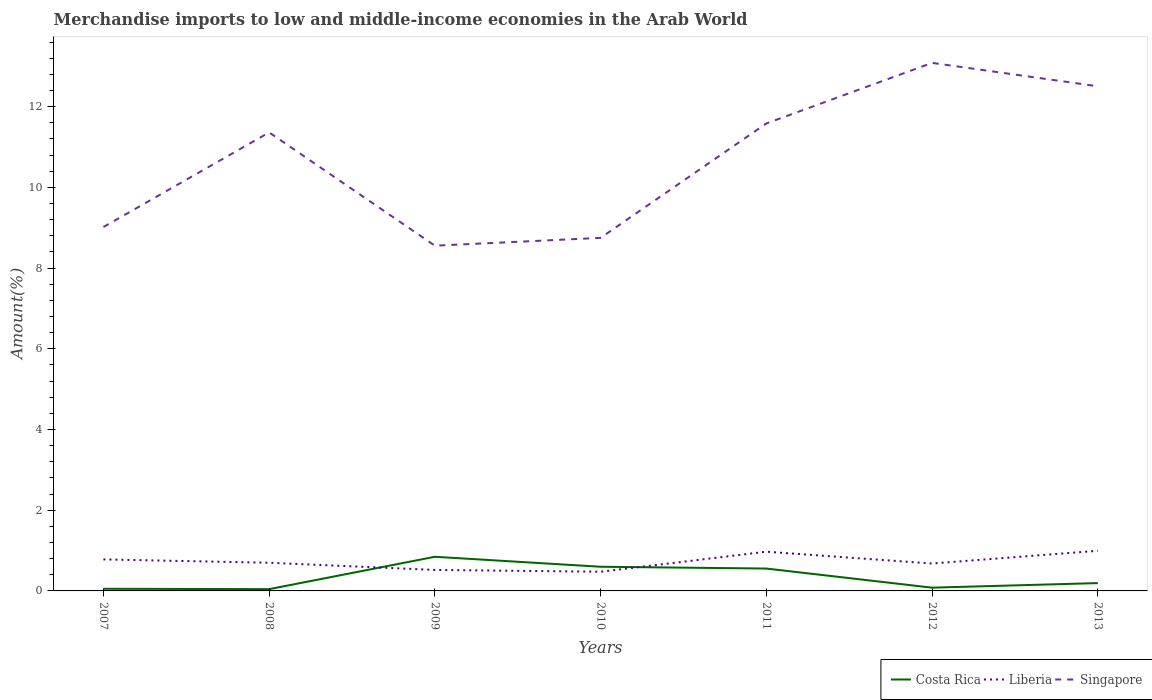Across all years, what is the maximum percentage of amount earned from merchandise imports in Costa Rica?
Offer a terse response. 0.04. In which year was the percentage of amount earned from merchandise imports in Singapore maximum?
Make the answer very short. 2009. What is the total percentage of amount earned from merchandise imports in Costa Rica in the graph?
Offer a very short reply. -0.51. What is the difference between the highest and the second highest percentage of amount earned from merchandise imports in Liberia?
Your response must be concise. 0.52. What is the difference between the highest and the lowest percentage of amount earned from merchandise imports in Singapore?
Provide a short and direct response. 4. How many lines are there?
Your response must be concise. 3. What is the difference between two consecutive major ticks on the Y-axis?
Keep it short and to the point. 2. Are the values on the major ticks of Y-axis written in scientific E-notation?
Provide a short and direct response. No. Does the graph contain any zero values?
Provide a succinct answer. No. Where does the legend appear in the graph?
Give a very brief answer. Bottom right. How many legend labels are there?
Your answer should be compact. 3. What is the title of the graph?
Give a very brief answer. Merchandise imports to low and middle-income economies in the Arab World. Does "Eritrea" appear as one of the legend labels in the graph?
Your response must be concise. No. What is the label or title of the Y-axis?
Your answer should be compact. Amount(%). What is the Amount(%) of Costa Rica in 2007?
Keep it short and to the point. 0.05. What is the Amount(%) of Liberia in 2007?
Provide a short and direct response. 0.78. What is the Amount(%) in Singapore in 2007?
Offer a very short reply. 9.02. What is the Amount(%) in Costa Rica in 2008?
Keep it short and to the point. 0.04. What is the Amount(%) of Liberia in 2008?
Give a very brief answer. 0.7. What is the Amount(%) in Singapore in 2008?
Make the answer very short. 11.36. What is the Amount(%) in Costa Rica in 2009?
Keep it short and to the point. 0.85. What is the Amount(%) in Liberia in 2009?
Offer a terse response. 0.52. What is the Amount(%) in Singapore in 2009?
Provide a short and direct response. 8.56. What is the Amount(%) of Costa Rica in 2010?
Give a very brief answer. 0.6. What is the Amount(%) in Liberia in 2010?
Give a very brief answer. 0.48. What is the Amount(%) of Singapore in 2010?
Ensure brevity in your answer.  8.75. What is the Amount(%) in Costa Rica in 2011?
Ensure brevity in your answer.  0.55. What is the Amount(%) of Liberia in 2011?
Make the answer very short. 0.97. What is the Amount(%) of Singapore in 2011?
Your answer should be compact. 11.58. What is the Amount(%) in Costa Rica in 2012?
Offer a very short reply. 0.08. What is the Amount(%) of Liberia in 2012?
Offer a very short reply. 0.68. What is the Amount(%) in Singapore in 2012?
Your response must be concise. 13.09. What is the Amount(%) of Costa Rica in 2013?
Offer a very short reply. 0.19. What is the Amount(%) of Liberia in 2013?
Provide a short and direct response. 0.99. What is the Amount(%) of Singapore in 2013?
Offer a terse response. 12.51. Across all years, what is the maximum Amount(%) in Costa Rica?
Your response must be concise. 0.85. Across all years, what is the maximum Amount(%) of Liberia?
Give a very brief answer. 0.99. Across all years, what is the maximum Amount(%) in Singapore?
Make the answer very short. 13.09. Across all years, what is the minimum Amount(%) in Costa Rica?
Ensure brevity in your answer.  0.04. Across all years, what is the minimum Amount(%) of Liberia?
Your answer should be very brief. 0.48. Across all years, what is the minimum Amount(%) in Singapore?
Offer a terse response. 8.56. What is the total Amount(%) of Costa Rica in the graph?
Your response must be concise. 2.37. What is the total Amount(%) in Liberia in the graph?
Provide a succinct answer. 5.12. What is the total Amount(%) of Singapore in the graph?
Offer a very short reply. 74.86. What is the difference between the Amount(%) of Costa Rica in 2007 and that in 2008?
Provide a short and direct response. 0.01. What is the difference between the Amount(%) of Liberia in 2007 and that in 2008?
Make the answer very short. 0.08. What is the difference between the Amount(%) of Singapore in 2007 and that in 2008?
Offer a very short reply. -2.34. What is the difference between the Amount(%) in Costa Rica in 2007 and that in 2009?
Offer a very short reply. -0.79. What is the difference between the Amount(%) of Liberia in 2007 and that in 2009?
Ensure brevity in your answer.  0.26. What is the difference between the Amount(%) of Singapore in 2007 and that in 2009?
Give a very brief answer. 0.46. What is the difference between the Amount(%) of Costa Rica in 2007 and that in 2010?
Keep it short and to the point. -0.55. What is the difference between the Amount(%) in Liberia in 2007 and that in 2010?
Make the answer very short. 0.31. What is the difference between the Amount(%) of Singapore in 2007 and that in 2010?
Offer a terse response. 0.27. What is the difference between the Amount(%) in Costa Rica in 2007 and that in 2011?
Your answer should be compact. -0.5. What is the difference between the Amount(%) in Liberia in 2007 and that in 2011?
Your response must be concise. -0.19. What is the difference between the Amount(%) of Singapore in 2007 and that in 2011?
Your answer should be very brief. -2.57. What is the difference between the Amount(%) of Costa Rica in 2007 and that in 2012?
Your answer should be very brief. -0.03. What is the difference between the Amount(%) in Liberia in 2007 and that in 2012?
Your response must be concise. 0.1. What is the difference between the Amount(%) of Singapore in 2007 and that in 2012?
Your answer should be very brief. -4.07. What is the difference between the Amount(%) in Costa Rica in 2007 and that in 2013?
Offer a terse response. -0.14. What is the difference between the Amount(%) in Liberia in 2007 and that in 2013?
Your answer should be very brief. -0.21. What is the difference between the Amount(%) of Singapore in 2007 and that in 2013?
Offer a terse response. -3.49. What is the difference between the Amount(%) in Costa Rica in 2008 and that in 2009?
Your answer should be very brief. -0.8. What is the difference between the Amount(%) in Liberia in 2008 and that in 2009?
Your answer should be compact. 0.18. What is the difference between the Amount(%) of Singapore in 2008 and that in 2009?
Provide a short and direct response. 2.81. What is the difference between the Amount(%) in Costa Rica in 2008 and that in 2010?
Give a very brief answer. -0.56. What is the difference between the Amount(%) in Liberia in 2008 and that in 2010?
Provide a succinct answer. 0.22. What is the difference between the Amount(%) in Singapore in 2008 and that in 2010?
Keep it short and to the point. 2.61. What is the difference between the Amount(%) of Costa Rica in 2008 and that in 2011?
Keep it short and to the point. -0.51. What is the difference between the Amount(%) of Liberia in 2008 and that in 2011?
Ensure brevity in your answer.  -0.27. What is the difference between the Amount(%) of Singapore in 2008 and that in 2011?
Your answer should be compact. -0.22. What is the difference between the Amount(%) of Costa Rica in 2008 and that in 2012?
Your answer should be compact. -0.04. What is the difference between the Amount(%) of Liberia in 2008 and that in 2012?
Offer a very short reply. 0.02. What is the difference between the Amount(%) in Singapore in 2008 and that in 2012?
Offer a very short reply. -1.72. What is the difference between the Amount(%) in Costa Rica in 2008 and that in 2013?
Keep it short and to the point. -0.15. What is the difference between the Amount(%) of Liberia in 2008 and that in 2013?
Provide a succinct answer. -0.3. What is the difference between the Amount(%) of Singapore in 2008 and that in 2013?
Ensure brevity in your answer.  -1.14. What is the difference between the Amount(%) of Costa Rica in 2009 and that in 2010?
Your response must be concise. 0.25. What is the difference between the Amount(%) in Liberia in 2009 and that in 2010?
Keep it short and to the point. 0.04. What is the difference between the Amount(%) in Singapore in 2009 and that in 2010?
Ensure brevity in your answer.  -0.19. What is the difference between the Amount(%) in Costa Rica in 2009 and that in 2011?
Give a very brief answer. 0.29. What is the difference between the Amount(%) of Liberia in 2009 and that in 2011?
Offer a very short reply. -0.45. What is the difference between the Amount(%) in Singapore in 2009 and that in 2011?
Your response must be concise. -3.03. What is the difference between the Amount(%) in Costa Rica in 2009 and that in 2012?
Provide a short and direct response. 0.77. What is the difference between the Amount(%) of Liberia in 2009 and that in 2012?
Provide a short and direct response. -0.16. What is the difference between the Amount(%) of Singapore in 2009 and that in 2012?
Make the answer very short. -4.53. What is the difference between the Amount(%) of Costa Rica in 2009 and that in 2013?
Offer a very short reply. 0.65. What is the difference between the Amount(%) of Liberia in 2009 and that in 2013?
Offer a terse response. -0.47. What is the difference between the Amount(%) in Singapore in 2009 and that in 2013?
Give a very brief answer. -3.95. What is the difference between the Amount(%) in Costa Rica in 2010 and that in 2011?
Your answer should be very brief. 0.04. What is the difference between the Amount(%) in Liberia in 2010 and that in 2011?
Your response must be concise. -0.5. What is the difference between the Amount(%) of Singapore in 2010 and that in 2011?
Give a very brief answer. -2.83. What is the difference between the Amount(%) in Costa Rica in 2010 and that in 2012?
Ensure brevity in your answer.  0.52. What is the difference between the Amount(%) of Liberia in 2010 and that in 2012?
Keep it short and to the point. -0.2. What is the difference between the Amount(%) in Singapore in 2010 and that in 2012?
Your answer should be compact. -4.34. What is the difference between the Amount(%) of Costa Rica in 2010 and that in 2013?
Your answer should be compact. 0.41. What is the difference between the Amount(%) of Liberia in 2010 and that in 2013?
Offer a very short reply. -0.52. What is the difference between the Amount(%) in Singapore in 2010 and that in 2013?
Offer a very short reply. -3.76. What is the difference between the Amount(%) of Costa Rica in 2011 and that in 2012?
Provide a succinct answer. 0.47. What is the difference between the Amount(%) in Liberia in 2011 and that in 2012?
Ensure brevity in your answer.  0.29. What is the difference between the Amount(%) of Singapore in 2011 and that in 2012?
Your answer should be compact. -1.5. What is the difference between the Amount(%) in Costa Rica in 2011 and that in 2013?
Offer a very short reply. 0.36. What is the difference between the Amount(%) in Liberia in 2011 and that in 2013?
Make the answer very short. -0.02. What is the difference between the Amount(%) in Singapore in 2011 and that in 2013?
Give a very brief answer. -0.92. What is the difference between the Amount(%) of Costa Rica in 2012 and that in 2013?
Provide a succinct answer. -0.11. What is the difference between the Amount(%) in Liberia in 2012 and that in 2013?
Provide a succinct answer. -0.32. What is the difference between the Amount(%) of Singapore in 2012 and that in 2013?
Provide a short and direct response. 0.58. What is the difference between the Amount(%) of Costa Rica in 2007 and the Amount(%) of Liberia in 2008?
Offer a very short reply. -0.65. What is the difference between the Amount(%) of Costa Rica in 2007 and the Amount(%) of Singapore in 2008?
Give a very brief answer. -11.31. What is the difference between the Amount(%) in Liberia in 2007 and the Amount(%) in Singapore in 2008?
Provide a short and direct response. -10.58. What is the difference between the Amount(%) of Costa Rica in 2007 and the Amount(%) of Liberia in 2009?
Offer a terse response. -0.47. What is the difference between the Amount(%) in Costa Rica in 2007 and the Amount(%) in Singapore in 2009?
Provide a short and direct response. -8.5. What is the difference between the Amount(%) in Liberia in 2007 and the Amount(%) in Singapore in 2009?
Give a very brief answer. -7.77. What is the difference between the Amount(%) of Costa Rica in 2007 and the Amount(%) of Liberia in 2010?
Your answer should be compact. -0.42. What is the difference between the Amount(%) of Costa Rica in 2007 and the Amount(%) of Singapore in 2010?
Give a very brief answer. -8.7. What is the difference between the Amount(%) of Liberia in 2007 and the Amount(%) of Singapore in 2010?
Offer a very short reply. -7.97. What is the difference between the Amount(%) of Costa Rica in 2007 and the Amount(%) of Liberia in 2011?
Give a very brief answer. -0.92. What is the difference between the Amount(%) in Costa Rica in 2007 and the Amount(%) in Singapore in 2011?
Your answer should be compact. -11.53. What is the difference between the Amount(%) of Liberia in 2007 and the Amount(%) of Singapore in 2011?
Offer a very short reply. -10.8. What is the difference between the Amount(%) in Costa Rica in 2007 and the Amount(%) in Liberia in 2012?
Provide a succinct answer. -0.63. What is the difference between the Amount(%) of Costa Rica in 2007 and the Amount(%) of Singapore in 2012?
Provide a succinct answer. -13.03. What is the difference between the Amount(%) of Liberia in 2007 and the Amount(%) of Singapore in 2012?
Give a very brief answer. -12.3. What is the difference between the Amount(%) of Costa Rica in 2007 and the Amount(%) of Liberia in 2013?
Offer a terse response. -0.94. What is the difference between the Amount(%) in Costa Rica in 2007 and the Amount(%) in Singapore in 2013?
Your answer should be very brief. -12.45. What is the difference between the Amount(%) in Liberia in 2007 and the Amount(%) in Singapore in 2013?
Provide a succinct answer. -11.72. What is the difference between the Amount(%) in Costa Rica in 2008 and the Amount(%) in Liberia in 2009?
Give a very brief answer. -0.48. What is the difference between the Amount(%) of Costa Rica in 2008 and the Amount(%) of Singapore in 2009?
Offer a terse response. -8.51. What is the difference between the Amount(%) of Liberia in 2008 and the Amount(%) of Singapore in 2009?
Provide a succinct answer. -7.86. What is the difference between the Amount(%) in Costa Rica in 2008 and the Amount(%) in Liberia in 2010?
Offer a very short reply. -0.43. What is the difference between the Amount(%) of Costa Rica in 2008 and the Amount(%) of Singapore in 2010?
Give a very brief answer. -8.71. What is the difference between the Amount(%) in Liberia in 2008 and the Amount(%) in Singapore in 2010?
Your answer should be compact. -8.05. What is the difference between the Amount(%) of Costa Rica in 2008 and the Amount(%) of Liberia in 2011?
Offer a terse response. -0.93. What is the difference between the Amount(%) of Costa Rica in 2008 and the Amount(%) of Singapore in 2011?
Make the answer very short. -11.54. What is the difference between the Amount(%) in Liberia in 2008 and the Amount(%) in Singapore in 2011?
Make the answer very short. -10.89. What is the difference between the Amount(%) of Costa Rica in 2008 and the Amount(%) of Liberia in 2012?
Offer a terse response. -0.64. What is the difference between the Amount(%) in Costa Rica in 2008 and the Amount(%) in Singapore in 2012?
Offer a terse response. -13.04. What is the difference between the Amount(%) in Liberia in 2008 and the Amount(%) in Singapore in 2012?
Offer a terse response. -12.39. What is the difference between the Amount(%) in Costa Rica in 2008 and the Amount(%) in Liberia in 2013?
Keep it short and to the point. -0.95. What is the difference between the Amount(%) of Costa Rica in 2008 and the Amount(%) of Singapore in 2013?
Offer a terse response. -12.46. What is the difference between the Amount(%) in Liberia in 2008 and the Amount(%) in Singapore in 2013?
Offer a terse response. -11.81. What is the difference between the Amount(%) in Costa Rica in 2009 and the Amount(%) in Liberia in 2010?
Your answer should be compact. 0.37. What is the difference between the Amount(%) of Costa Rica in 2009 and the Amount(%) of Singapore in 2010?
Your response must be concise. -7.9. What is the difference between the Amount(%) in Liberia in 2009 and the Amount(%) in Singapore in 2010?
Ensure brevity in your answer.  -8.23. What is the difference between the Amount(%) in Costa Rica in 2009 and the Amount(%) in Liberia in 2011?
Give a very brief answer. -0.13. What is the difference between the Amount(%) in Costa Rica in 2009 and the Amount(%) in Singapore in 2011?
Make the answer very short. -10.74. What is the difference between the Amount(%) of Liberia in 2009 and the Amount(%) of Singapore in 2011?
Make the answer very short. -11.06. What is the difference between the Amount(%) in Costa Rica in 2009 and the Amount(%) in Liberia in 2012?
Provide a short and direct response. 0.17. What is the difference between the Amount(%) of Costa Rica in 2009 and the Amount(%) of Singapore in 2012?
Keep it short and to the point. -12.24. What is the difference between the Amount(%) in Liberia in 2009 and the Amount(%) in Singapore in 2012?
Your answer should be very brief. -12.57. What is the difference between the Amount(%) of Costa Rica in 2009 and the Amount(%) of Liberia in 2013?
Your response must be concise. -0.15. What is the difference between the Amount(%) in Costa Rica in 2009 and the Amount(%) in Singapore in 2013?
Provide a short and direct response. -11.66. What is the difference between the Amount(%) in Liberia in 2009 and the Amount(%) in Singapore in 2013?
Your answer should be very brief. -11.99. What is the difference between the Amount(%) in Costa Rica in 2010 and the Amount(%) in Liberia in 2011?
Offer a terse response. -0.37. What is the difference between the Amount(%) in Costa Rica in 2010 and the Amount(%) in Singapore in 2011?
Your response must be concise. -10.99. What is the difference between the Amount(%) in Liberia in 2010 and the Amount(%) in Singapore in 2011?
Give a very brief answer. -11.11. What is the difference between the Amount(%) in Costa Rica in 2010 and the Amount(%) in Liberia in 2012?
Provide a succinct answer. -0.08. What is the difference between the Amount(%) of Costa Rica in 2010 and the Amount(%) of Singapore in 2012?
Ensure brevity in your answer.  -12.49. What is the difference between the Amount(%) of Liberia in 2010 and the Amount(%) of Singapore in 2012?
Provide a short and direct response. -12.61. What is the difference between the Amount(%) of Costa Rica in 2010 and the Amount(%) of Liberia in 2013?
Provide a short and direct response. -0.4. What is the difference between the Amount(%) of Costa Rica in 2010 and the Amount(%) of Singapore in 2013?
Provide a short and direct response. -11.91. What is the difference between the Amount(%) of Liberia in 2010 and the Amount(%) of Singapore in 2013?
Provide a succinct answer. -12.03. What is the difference between the Amount(%) of Costa Rica in 2011 and the Amount(%) of Liberia in 2012?
Make the answer very short. -0.12. What is the difference between the Amount(%) of Costa Rica in 2011 and the Amount(%) of Singapore in 2012?
Your response must be concise. -12.53. What is the difference between the Amount(%) of Liberia in 2011 and the Amount(%) of Singapore in 2012?
Offer a very short reply. -12.11. What is the difference between the Amount(%) of Costa Rica in 2011 and the Amount(%) of Liberia in 2013?
Ensure brevity in your answer.  -0.44. What is the difference between the Amount(%) in Costa Rica in 2011 and the Amount(%) in Singapore in 2013?
Ensure brevity in your answer.  -11.95. What is the difference between the Amount(%) of Liberia in 2011 and the Amount(%) of Singapore in 2013?
Provide a succinct answer. -11.53. What is the difference between the Amount(%) of Costa Rica in 2012 and the Amount(%) of Liberia in 2013?
Make the answer very short. -0.91. What is the difference between the Amount(%) of Costa Rica in 2012 and the Amount(%) of Singapore in 2013?
Provide a succinct answer. -12.43. What is the difference between the Amount(%) of Liberia in 2012 and the Amount(%) of Singapore in 2013?
Provide a succinct answer. -11.83. What is the average Amount(%) in Costa Rica per year?
Keep it short and to the point. 0.34. What is the average Amount(%) in Liberia per year?
Make the answer very short. 0.73. What is the average Amount(%) in Singapore per year?
Provide a succinct answer. 10.69. In the year 2007, what is the difference between the Amount(%) of Costa Rica and Amount(%) of Liberia?
Your answer should be compact. -0.73. In the year 2007, what is the difference between the Amount(%) of Costa Rica and Amount(%) of Singapore?
Provide a short and direct response. -8.97. In the year 2007, what is the difference between the Amount(%) in Liberia and Amount(%) in Singapore?
Your answer should be very brief. -8.24. In the year 2008, what is the difference between the Amount(%) of Costa Rica and Amount(%) of Liberia?
Your response must be concise. -0.65. In the year 2008, what is the difference between the Amount(%) in Costa Rica and Amount(%) in Singapore?
Make the answer very short. -11.32. In the year 2008, what is the difference between the Amount(%) of Liberia and Amount(%) of Singapore?
Ensure brevity in your answer.  -10.66. In the year 2009, what is the difference between the Amount(%) of Costa Rica and Amount(%) of Liberia?
Your response must be concise. 0.33. In the year 2009, what is the difference between the Amount(%) in Costa Rica and Amount(%) in Singapore?
Your response must be concise. -7.71. In the year 2009, what is the difference between the Amount(%) in Liberia and Amount(%) in Singapore?
Your answer should be compact. -8.03. In the year 2010, what is the difference between the Amount(%) of Costa Rica and Amount(%) of Liberia?
Your answer should be compact. 0.12. In the year 2010, what is the difference between the Amount(%) in Costa Rica and Amount(%) in Singapore?
Offer a terse response. -8.15. In the year 2010, what is the difference between the Amount(%) in Liberia and Amount(%) in Singapore?
Offer a terse response. -8.27. In the year 2011, what is the difference between the Amount(%) in Costa Rica and Amount(%) in Liberia?
Make the answer very short. -0.42. In the year 2011, what is the difference between the Amount(%) of Costa Rica and Amount(%) of Singapore?
Provide a short and direct response. -11.03. In the year 2011, what is the difference between the Amount(%) in Liberia and Amount(%) in Singapore?
Ensure brevity in your answer.  -10.61. In the year 2012, what is the difference between the Amount(%) of Costa Rica and Amount(%) of Liberia?
Provide a succinct answer. -0.6. In the year 2012, what is the difference between the Amount(%) of Costa Rica and Amount(%) of Singapore?
Your answer should be very brief. -13. In the year 2012, what is the difference between the Amount(%) of Liberia and Amount(%) of Singapore?
Provide a short and direct response. -12.41. In the year 2013, what is the difference between the Amount(%) in Costa Rica and Amount(%) in Liberia?
Your answer should be very brief. -0.8. In the year 2013, what is the difference between the Amount(%) of Costa Rica and Amount(%) of Singapore?
Give a very brief answer. -12.31. In the year 2013, what is the difference between the Amount(%) in Liberia and Amount(%) in Singapore?
Make the answer very short. -11.51. What is the ratio of the Amount(%) of Costa Rica in 2007 to that in 2008?
Provide a succinct answer. 1.21. What is the ratio of the Amount(%) of Liberia in 2007 to that in 2008?
Offer a terse response. 1.12. What is the ratio of the Amount(%) in Singapore in 2007 to that in 2008?
Give a very brief answer. 0.79. What is the ratio of the Amount(%) of Costa Rica in 2007 to that in 2009?
Your answer should be very brief. 0.06. What is the ratio of the Amount(%) of Liberia in 2007 to that in 2009?
Keep it short and to the point. 1.5. What is the ratio of the Amount(%) in Singapore in 2007 to that in 2009?
Offer a terse response. 1.05. What is the ratio of the Amount(%) in Costa Rica in 2007 to that in 2010?
Your response must be concise. 0.09. What is the ratio of the Amount(%) in Liberia in 2007 to that in 2010?
Keep it short and to the point. 1.64. What is the ratio of the Amount(%) of Singapore in 2007 to that in 2010?
Ensure brevity in your answer.  1.03. What is the ratio of the Amount(%) in Costa Rica in 2007 to that in 2011?
Provide a succinct answer. 0.1. What is the ratio of the Amount(%) of Liberia in 2007 to that in 2011?
Your answer should be very brief. 0.8. What is the ratio of the Amount(%) of Singapore in 2007 to that in 2011?
Your answer should be compact. 0.78. What is the ratio of the Amount(%) in Costa Rica in 2007 to that in 2012?
Provide a short and direct response. 0.66. What is the ratio of the Amount(%) in Liberia in 2007 to that in 2012?
Your answer should be very brief. 1.15. What is the ratio of the Amount(%) of Singapore in 2007 to that in 2012?
Your answer should be very brief. 0.69. What is the ratio of the Amount(%) in Costa Rica in 2007 to that in 2013?
Make the answer very short. 0.27. What is the ratio of the Amount(%) of Liberia in 2007 to that in 2013?
Give a very brief answer. 0.79. What is the ratio of the Amount(%) of Singapore in 2007 to that in 2013?
Give a very brief answer. 0.72. What is the ratio of the Amount(%) in Costa Rica in 2008 to that in 2009?
Your response must be concise. 0.05. What is the ratio of the Amount(%) in Liberia in 2008 to that in 2009?
Give a very brief answer. 1.34. What is the ratio of the Amount(%) of Singapore in 2008 to that in 2009?
Keep it short and to the point. 1.33. What is the ratio of the Amount(%) of Costa Rica in 2008 to that in 2010?
Your response must be concise. 0.07. What is the ratio of the Amount(%) in Liberia in 2008 to that in 2010?
Your response must be concise. 1.47. What is the ratio of the Amount(%) of Singapore in 2008 to that in 2010?
Give a very brief answer. 1.3. What is the ratio of the Amount(%) in Costa Rica in 2008 to that in 2011?
Your answer should be very brief. 0.08. What is the ratio of the Amount(%) in Liberia in 2008 to that in 2011?
Provide a short and direct response. 0.72. What is the ratio of the Amount(%) in Singapore in 2008 to that in 2011?
Offer a very short reply. 0.98. What is the ratio of the Amount(%) in Costa Rica in 2008 to that in 2012?
Give a very brief answer. 0.55. What is the ratio of the Amount(%) of Liberia in 2008 to that in 2012?
Offer a terse response. 1.03. What is the ratio of the Amount(%) of Singapore in 2008 to that in 2012?
Your response must be concise. 0.87. What is the ratio of the Amount(%) in Costa Rica in 2008 to that in 2013?
Your answer should be compact. 0.23. What is the ratio of the Amount(%) of Liberia in 2008 to that in 2013?
Provide a short and direct response. 0.7. What is the ratio of the Amount(%) of Singapore in 2008 to that in 2013?
Your response must be concise. 0.91. What is the ratio of the Amount(%) in Costa Rica in 2009 to that in 2010?
Offer a very short reply. 1.41. What is the ratio of the Amount(%) in Liberia in 2009 to that in 2010?
Provide a short and direct response. 1.09. What is the ratio of the Amount(%) in Singapore in 2009 to that in 2010?
Provide a short and direct response. 0.98. What is the ratio of the Amount(%) of Costa Rica in 2009 to that in 2011?
Your response must be concise. 1.53. What is the ratio of the Amount(%) in Liberia in 2009 to that in 2011?
Provide a succinct answer. 0.54. What is the ratio of the Amount(%) of Singapore in 2009 to that in 2011?
Your answer should be very brief. 0.74. What is the ratio of the Amount(%) of Costa Rica in 2009 to that in 2012?
Provide a succinct answer. 10.48. What is the ratio of the Amount(%) of Liberia in 2009 to that in 2012?
Provide a short and direct response. 0.77. What is the ratio of the Amount(%) of Singapore in 2009 to that in 2012?
Your response must be concise. 0.65. What is the ratio of the Amount(%) of Costa Rica in 2009 to that in 2013?
Provide a succinct answer. 4.36. What is the ratio of the Amount(%) of Liberia in 2009 to that in 2013?
Your answer should be very brief. 0.52. What is the ratio of the Amount(%) in Singapore in 2009 to that in 2013?
Your answer should be compact. 0.68. What is the ratio of the Amount(%) of Costa Rica in 2010 to that in 2011?
Offer a very short reply. 1.08. What is the ratio of the Amount(%) of Liberia in 2010 to that in 2011?
Ensure brevity in your answer.  0.49. What is the ratio of the Amount(%) in Singapore in 2010 to that in 2011?
Give a very brief answer. 0.76. What is the ratio of the Amount(%) in Costa Rica in 2010 to that in 2012?
Your response must be concise. 7.42. What is the ratio of the Amount(%) in Liberia in 2010 to that in 2012?
Your answer should be very brief. 0.7. What is the ratio of the Amount(%) in Singapore in 2010 to that in 2012?
Offer a terse response. 0.67. What is the ratio of the Amount(%) of Costa Rica in 2010 to that in 2013?
Keep it short and to the point. 3.09. What is the ratio of the Amount(%) of Liberia in 2010 to that in 2013?
Give a very brief answer. 0.48. What is the ratio of the Amount(%) of Singapore in 2010 to that in 2013?
Your answer should be compact. 0.7. What is the ratio of the Amount(%) of Costa Rica in 2011 to that in 2012?
Keep it short and to the point. 6.87. What is the ratio of the Amount(%) of Liberia in 2011 to that in 2012?
Give a very brief answer. 1.43. What is the ratio of the Amount(%) in Singapore in 2011 to that in 2012?
Make the answer very short. 0.89. What is the ratio of the Amount(%) in Costa Rica in 2011 to that in 2013?
Your response must be concise. 2.86. What is the ratio of the Amount(%) in Liberia in 2011 to that in 2013?
Your answer should be very brief. 0.98. What is the ratio of the Amount(%) in Singapore in 2011 to that in 2013?
Your answer should be compact. 0.93. What is the ratio of the Amount(%) of Costa Rica in 2012 to that in 2013?
Your answer should be very brief. 0.42. What is the ratio of the Amount(%) of Liberia in 2012 to that in 2013?
Provide a short and direct response. 0.68. What is the ratio of the Amount(%) in Singapore in 2012 to that in 2013?
Your answer should be very brief. 1.05. What is the difference between the highest and the second highest Amount(%) of Costa Rica?
Offer a terse response. 0.25. What is the difference between the highest and the second highest Amount(%) of Liberia?
Ensure brevity in your answer.  0.02. What is the difference between the highest and the second highest Amount(%) of Singapore?
Offer a terse response. 0.58. What is the difference between the highest and the lowest Amount(%) of Costa Rica?
Keep it short and to the point. 0.8. What is the difference between the highest and the lowest Amount(%) of Liberia?
Give a very brief answer. 0.52. What is the difference between the highest and the lowest Amount(%) in Singapore?
Your answer should be compact. 4.53. 